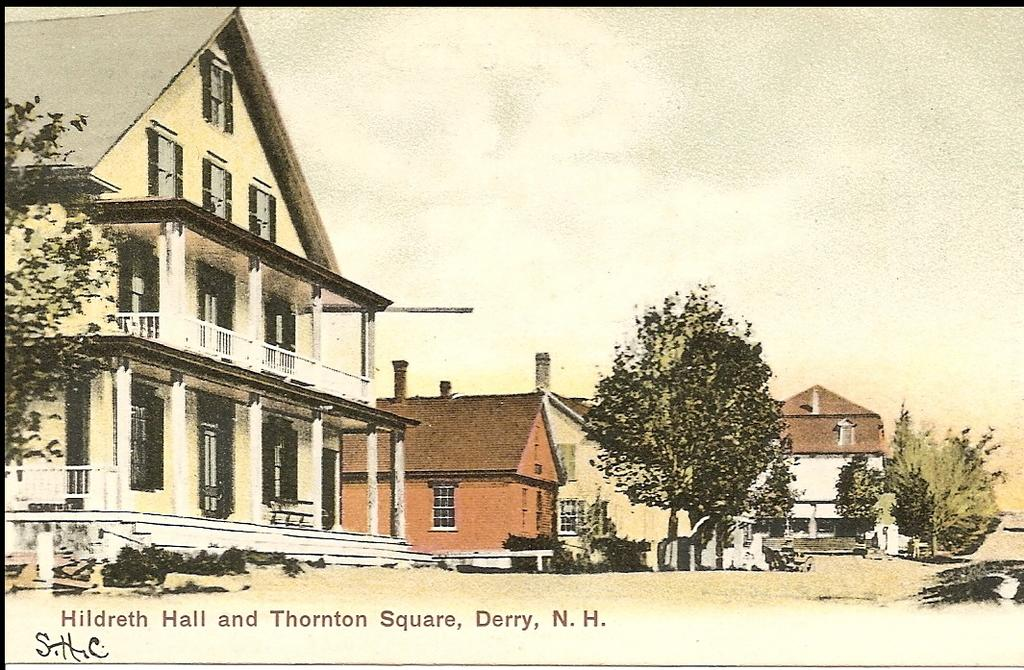What is depicted on the paper in the image? The paper contains an image or drawing. What elements can be found in the depicted image or drawing? The image or drawing includes trees, buildings, and plants. What type of treatment is being applied to the plants in the image? There is no treatment being applied to the plants in the image; the image or drawing only depicts the plants. 